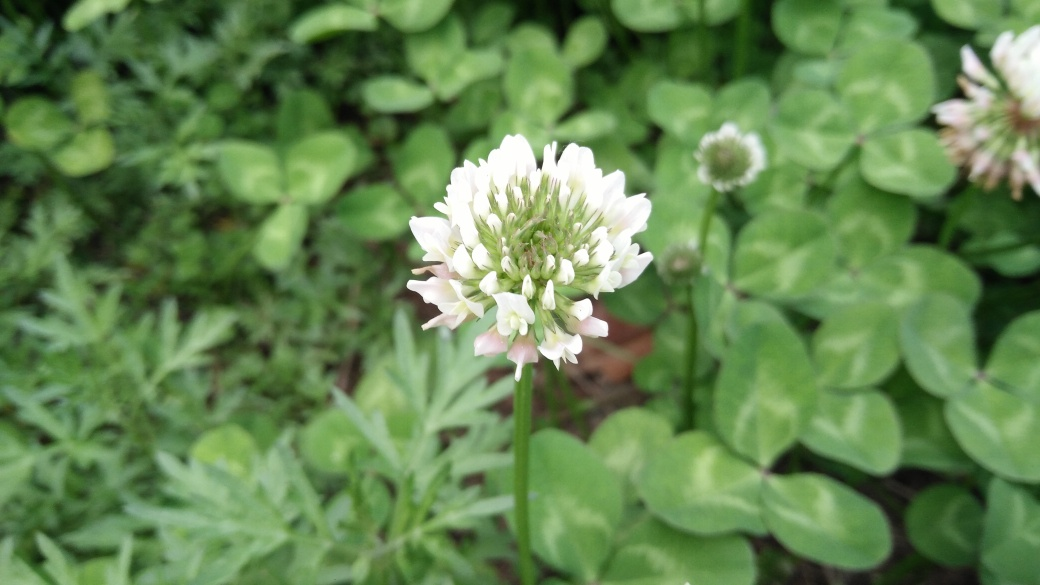Do clover flowers have any significance or uses? Yes, clover flowers have multiple uses and significances. Agriculturally, they are used as a cover crop to enrich soil with nitrogen. In folklore, finding a four-leaf clover is considered a sign of good luck. Additionally, clover flowers are edible and can be used in salads or as garnishes. Are these plants beneficial for the ecosystem in any way? Absolutely, clovers are beneficial for the ecosystem as they are nitrogen fixers, which help to improve soil fertility. Also, their flowers are a valuable food source for pollinators like bees and butterflies, contributing to the health and diversity of the ecosystem. 